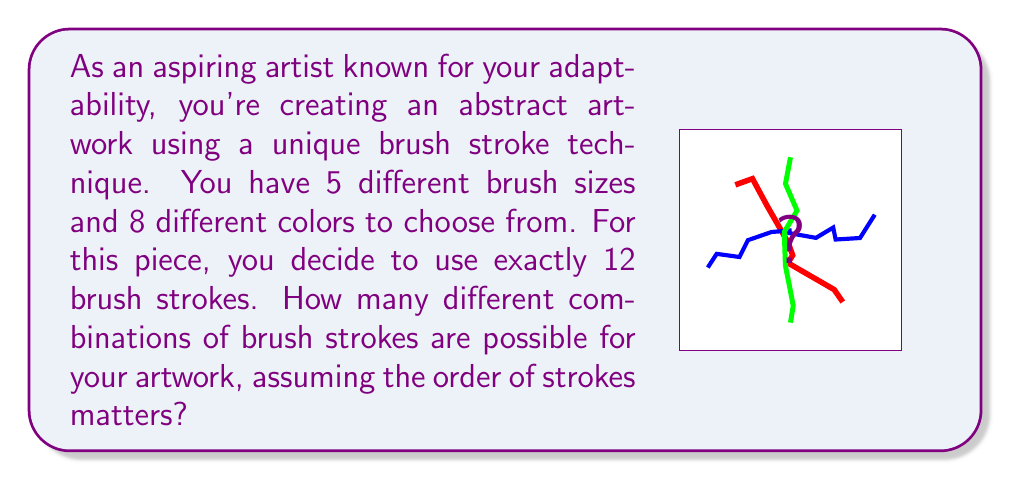Teach me how to tackle this problem. Let's approach this step-by-step:

1) First, we need to understand what we're counting. For each brush stroke, we need to choose both a brush size and a color.

2) For each stroke, we have:
   - 5 choices for brush size
   - 8 choices for color

3) This means that for each individual stroke, we have $5 \times 8 = 40$ possible combinations.

4) Now, we need to make this choice 12 times (for 12 strokes), and the order matters (as specified in the question).

5) This scenario is a perfect example of the multiplication principle in combinatorics. When we have a sequence of independent choices, we multiply the number of possibilities for each choice.

6) Therefore, the total number of possible combinations is:

   $$ 40 \times 40 \times 40 \times ... \text{ (12 times) } ... \times 40 $$

7) This can be written more concisely as:

   $$ 40^{12} $$

8) Calculating this:
   $$ 40^{12} = 1,677,721,600,000,000 $$

Thus, there are 1,677,721,600,000,000 possible combinations of brush strokes for your abstract artwork.
Answer: $40^{12} = 1,677,721,600,000,000$ 